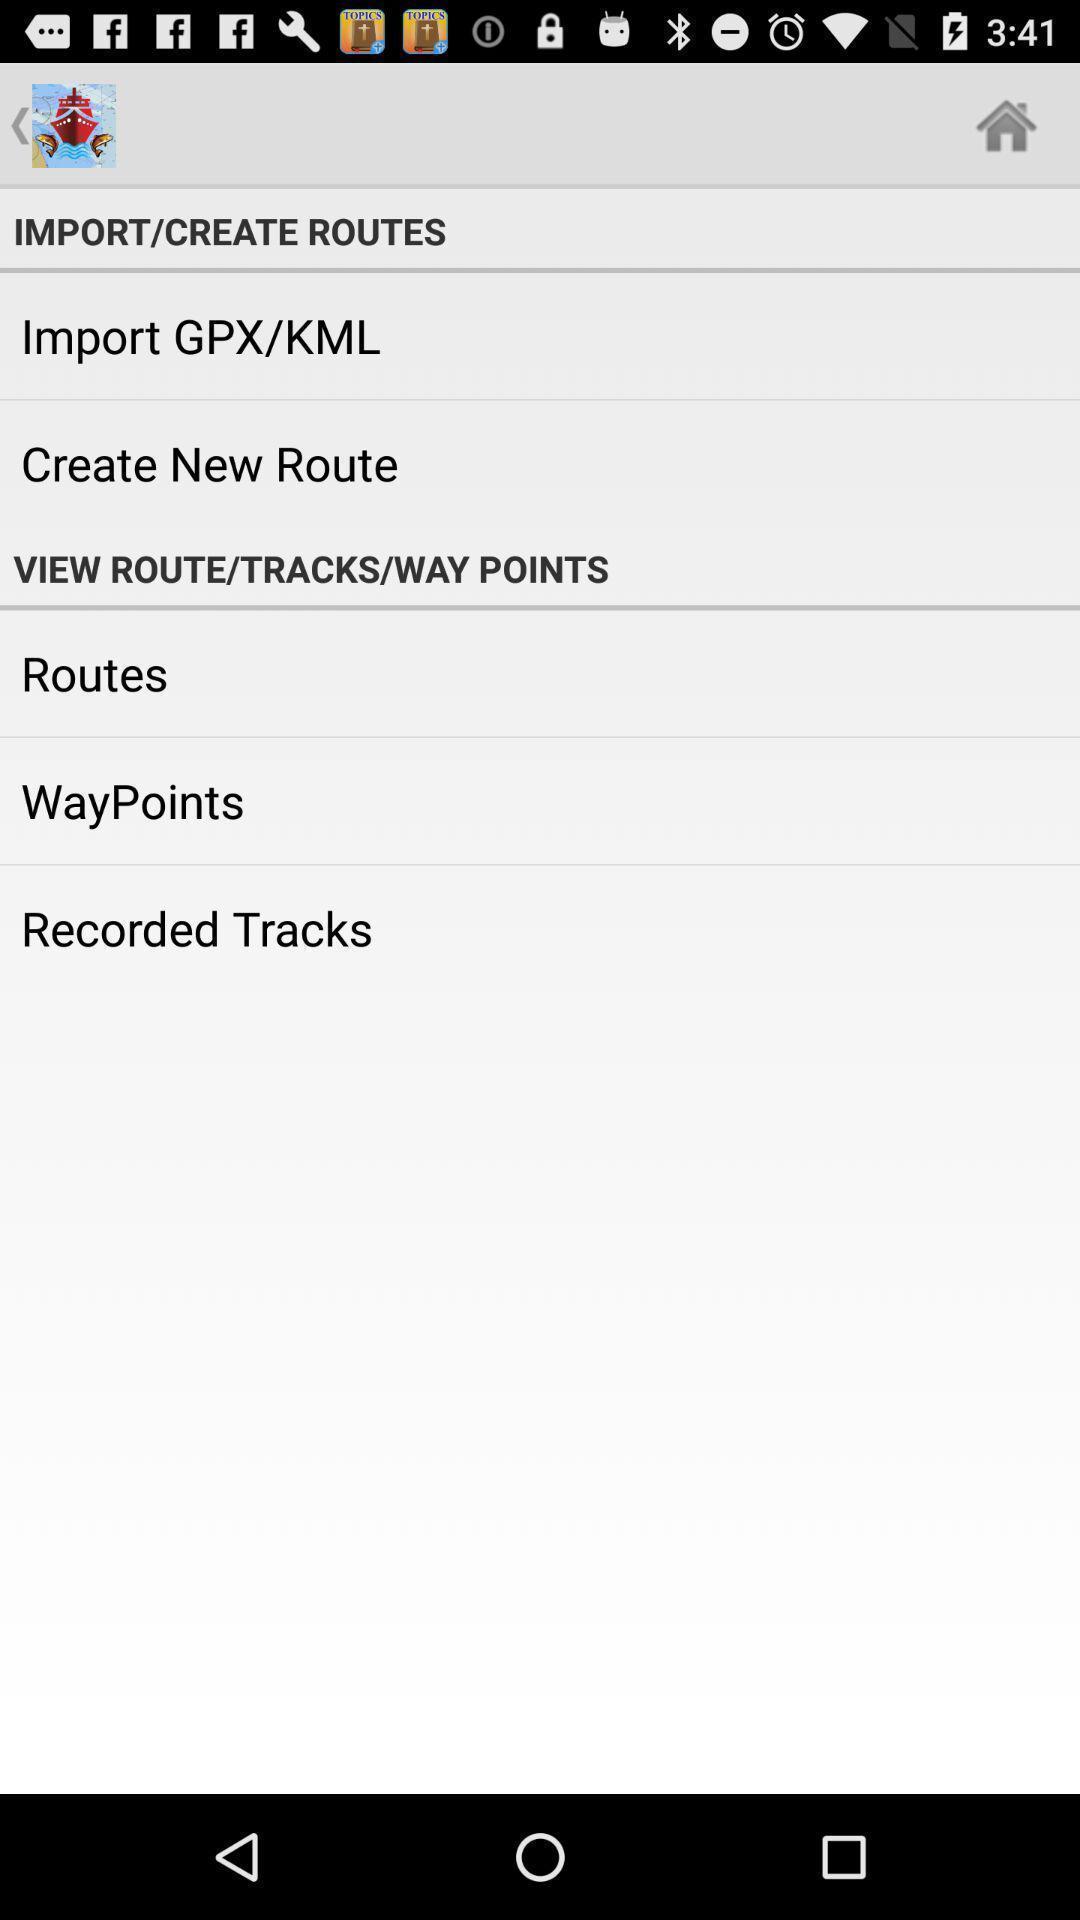Summarize the information in this screenshot. Screen showing import and create routes options. 